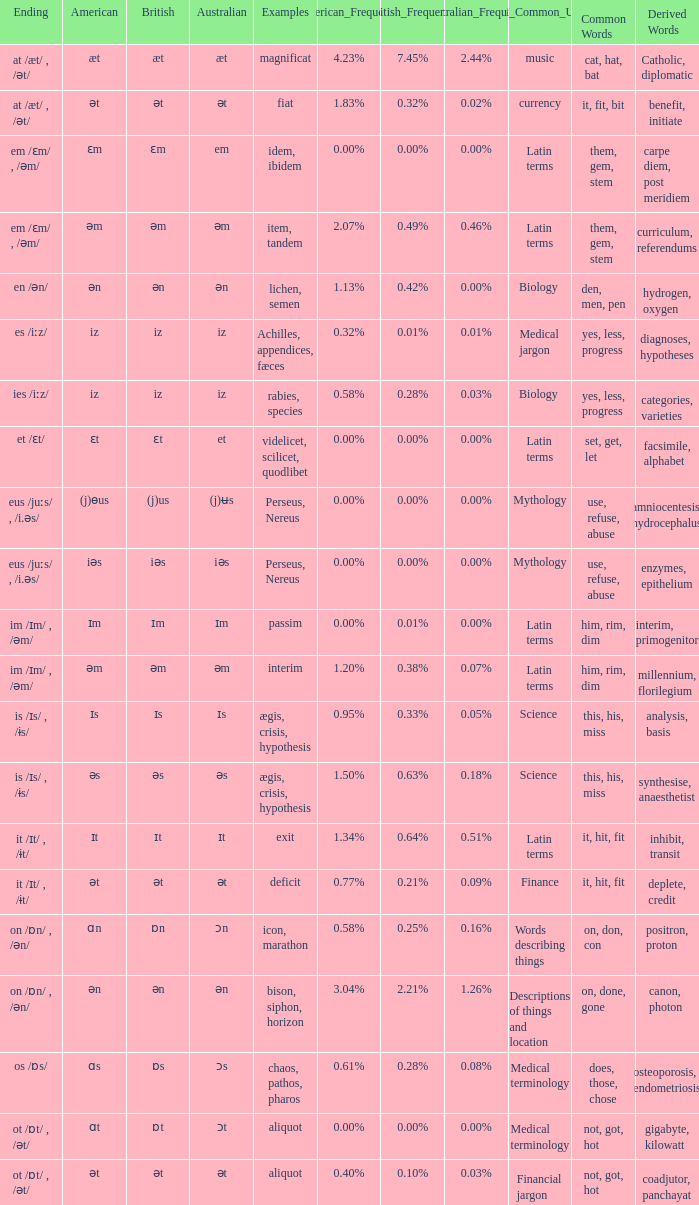Which Examples has Australian of əm? Item, tandem, interim. 